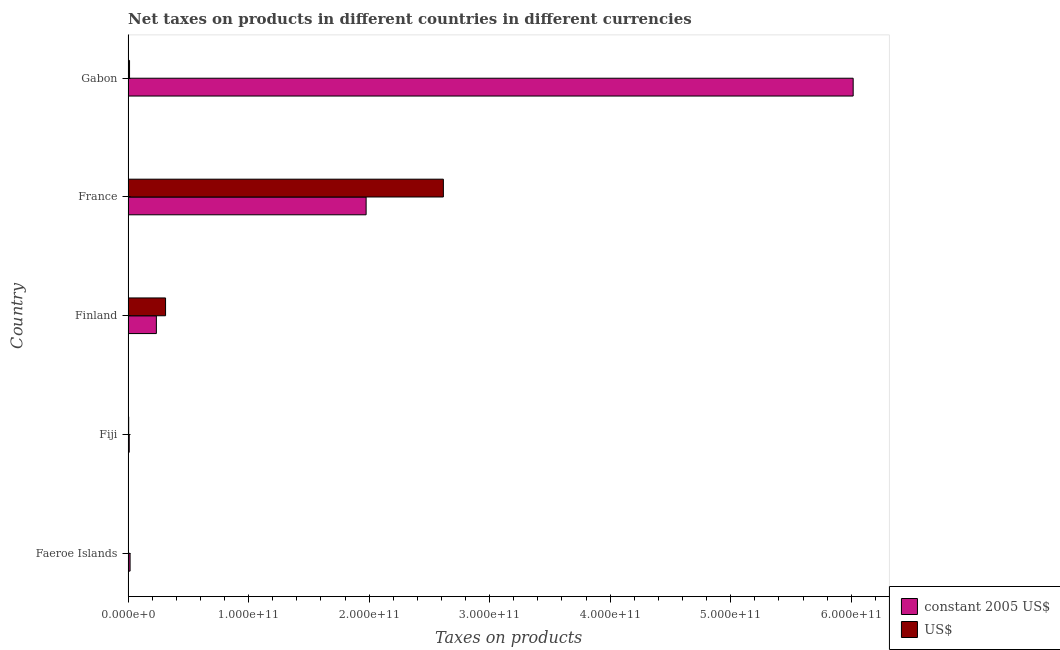How many groups of bars are there?
Offer a terse response. 5. How many bars are there on the 1st tick from the bottom?
Make the answer very short. 2. What is the label of the 4th group of bars from the top?
Provide a succinct answer. Fiji. In how many cases, is the number of bars for a given country not equal to the number of legend labels?
Your answer should be compact. 0. What is the net taxes in us$ in Fiji?
Offer a very short reply. 5.07e+08. Across all countries, what is the maximum net taxes in constant 2005 us$?
Offer a very short reply. 6.02e+11. Across all countries, what is the minimum net taxes in us$?
Your response must be concise. 2.96e+08. In which country was the net taxes in us$ maximum?
Provide a short and direct response. France. In which country was the net taxes in constant 2005 us$ minimum?
Your answer should be compact. Fiji. What is the total net taxes in us$ in the graph?
Offer a very short reply. 2.95e+11. What is the difference between the net taxes in us$ in Finland and that in Gabon?
Make the answer very short. 2.99e+1. What is the difference between the net taxes in us$ in Faeroe Islands and the net taxes in constant 2005 us$ in France?
Offer a terse response. -1.97e+11. What is the average net taxes in constant 2005 us$ per country?
Provide a succinct answer. 1.65e+11. What is the difference between the net taxes in constant 2005 us$ and net taxes in us$ in Finland?
Provide a short and direct response. -7.62e+09. What is the ratio of the net taxes in us$ in Faeroe Islands to that in Finland?
Provide a short and direct response. 0.01. Is the net taxes in us$ in Fiji less than that in Finland?
Give a very brief answer. Yes. Is the difference between the net taxes in us$ in Faeroe Islands and Finland greater than the difference between the net taxes in constant 2005 us$ in Faeroe Islands and Finland?
Offer a terse response. No. What is the difference between the highest and the second highest net taxes in constant 2005 us$?
Provide a succinct answer. 4.04e+11. What is the difference between the highest and the lowest net taxes in constant 2005 us$?
Make the answer very short. 6.01e+11. Is the sum of the net taxes in constant 2005 us$ in Faeroe Islands and France greater than the maximum net taxes in us$ across all countries?
Make the answer very short. No. What does the 2nd bar from the top in Finland represents?
Give a very brief answer. Constant 2005 us$. What does the 1st bar from the bottom in Finland represents?
Provide a succinct answer. Constant 2005 us$. How many bars are there?
Offer a terse response. 10. Are all the bars in the graph horizontal?
Ensure brevity in your answer.  Yes. How many countries are there in the graph?
Offer a terse response. 5. What is the difference between two consecutive major ticks on the X-axis?
Your answer should be very brief. 1.00e+11. Are the values on the major ticks of X-axis written in scientific E-notation?
Ensure brevity in your answer.  Yes. Does the graph contain any zero values?
Your answer should be very brief. No. How many legend labels are there?
Offer a terse response. 2. What is the title of the graph?
Your answer should be compact. Net taxes on products in different countries in different currencies. Does "Female population" appear as one of the legend labels in the graph?
Provide a succinct answer. No. What is the label or title of the X-axis?
Ensure brevity in your answer.  Taxes on products. What is the Taxes on products in constant 2005 US$ in Faeroe Islands?
Ensure brevity in your answer.  1.67e+09. What is the Taxes on products in US$ in Faeroe Islands?
Your answer should be very brief. 2.96e+08. What is the Taxes on products of constant 2005 US$ in Fiji?
Your answer should be compact. 9.73e+08. What is the Taxes on products in US$ in Fiji?
Provide a short and direct response. 5.07e+08. What is the Taxes on products of constant 2005 US$ in Finland?
Provide a short and direct response. 2.35e+1. What is the Taxes on products in US$ in Finland?
Offer a very short reply. 3.11e+1. What is the Taxes on products of constant 2005 US$ in France?
Ensure brevity in your answer.  1.97e+11. What is the Taxes on products in US$ in France?
Offer a very short reply. 2.62e+11. What is the Taxes on products in constant 2005 US$ in Gabon?
Your answer should be very brief. 6.02e+11. What is the Taxes on products of US$ in Gabon?
Offer a terse response. 1.21e+09. Across all countries, what is the maximum Taxes on products in constant 2005 US$?
Ensure brevity in your answer.  6.02e+11. Across all countries, what is the maximum Taxes on products of US$?
Your answer should be very brief. 2.62e+11. Across all countries, what is the minimum Taxes on products in constant 2005 US$?
Give a very brief answer. 9.73e+08. Across all countries, what is the minimum Taxes on products of US$?
Your response must be concise. 2.96e+08. What is the total Taxes on products of constant 2005 US$ in the graph?
Ensure brevity in your answer.  8.25e+11. What is the total Taxes on products of US$ in the graph?
Keep it short and to the point. 2.95e+11. What is the difference between the Taxes on products in constant 2005 US$ in Faeroe Islands and that in Fiji?
Ensure brevity in your answer.  6.93e+08. What is the difference between the Taxes on products in US$ in Faeroe Islands and that in Fiji?
Keep it short and to the point. -2.11e+08. What is the difference between the Taxes on products in constant 2005 US$ in Faeroe Islands and that in Finland?
Your response must be concise. -2.18e+1. What is the difference between the Taxes on products of US$ in Faeroe Islands and that in Finland?
Keep it short and to the point. -3.08e+1. What is the difference between the Taxes on products in constant 2005 US$ in Faeroe Islands and that in France?
Provide a succinct answer. -1.96e+11. What is the difference between the Taxes on products in US$ in Faeroe Islands and that in France?
Keep it short and to the point. -2.61e+11. What is the difference between the Taxes on products in constant 2005 US$ in Faeroe Islands and that in Gabon?
Provide a short and direct response. -6.00e+11. What is the difference between the Taxes on products in US$ in Faeroe Islands and that in Gabon?
Your response must be concise. -9.18e+08. What is the difference between the Taxes on products of constant 2005 US$ in Fiji and that in Finland?
Keep it short and to the point. -2.25e+1. What is the difference between the Taxes on products of US$ in Fiji and that in Finland?
Your answer should be very brief. -3.06e+1. What is the difference between the Taxes on products of constant 2005 US$ in Fiji and that in France?
Your answer should be very brief. -1.97e+11. What is the difference between the Taxes on products of US$ in Fiji and that in France?
Ensure brevity in your answer.  -2.61e+11. What is the difference between the Taxes on products in constant 2005 US$ in Fiji and that in Gabon?
Make the answer very short. -6.01e+11. What is the difference between the Taxes on products of US$ in Fiji and that in Gabon?
Provide a short and direct response. -7.07e+08. What is the difference between the Taxes on products in constant 2005 US$ in Finland and that in France?
Keep it short and to the point. -1.74e+11. What is the difference between the Taxes on products of US$ in Finland and that in France?
Make the answer very short. -2.30e+11. What is the difference between the Taxes on products in constant 2005 US$ in Finland and that in Gabon?
Offer a very short reply. -5.78e+11. What is the difference between the Taxes on products in US$ in Finland and that in Gabon?
Keep it short and to the point. 2.99e+1. What is the difference between the Taxes on products of constant 2005 US$ in France and that in Gabon?
Offer a very short reply. -4.04e+11. What is the difference between the Taxes on products of US$ in France and that in Gabon?
Provide a short and direct response. 2.60e+11. What is the difference between the Taxes on products in constant 2005 US$ in Faeroe Islands and the Taxes on products in US$ in Fiji?
Make the answer very short. 1.16e+09. What is the difference between the Taxes on products of constant 2005 US$ in Faeroe Islands and the Taxes on products of US$ in Finland?
Ensure brevity in your answer.  -2.94e+1. What is the difference between the Taxes on products in constant 2005 US$ in Faeroe Islands and the Taxes on products in US$ in France?
Your answer should be very brief. -2.60e+11. What is the difference between the Taxes on products of constant 2005 US$ in Faeroe Islands and the Taxes on products of US$ in Gabon?
Provide a short and direct response. 4.51e+08. What is the difference between the Taxes on products of constant 2005 US$ in Fiji and the Taxes on products of US$ in Finland?
Keep it short and to the point. -3.01e+1. What is the difference between the Taxes on products of constant 2005 US$ in Fiji and the Taxes on products of US$ in France?
Your answer should be very brief. -2.61e+11. What is the difference between the Taxes on products in constant 2005 US$ in Fiji and the Taxes on products in US$ in Gabon?
Make the answer very short. -2.41e+08. What is the difference between the Taxes on products in constant 2005 US$ in Finland and the Taxes on products in US$ in France?
Keep it short and to the point. -2.38e+11. What is the difference between the Taxes on products in constant 2005 US$ in Finland and the Taxes on products in US$ in Gabon?
Your answer should be very brief. 2.23e+1. What is the difference between the Taxes on products of constant 2005 US$ in France and the Taxes on products of US$ in Gabon?
Your answer should be very brief. 1.96e+11. What is the average Taxes on products of constant 2005 US$ per country?
Your answer should be compact. 1.65e+11. What is the average Taxes on products in US$ per country?
Ensure brevity in your answer.  5.89e+1. What is the difference between the Taxes on products of constant 2005 US$ and Taxes on products of US$ in Faeroe Islands?
Provide a succinct answer. 1.37e+09. What is the difference between the Taxes on products in constant 2005 US$ and Taxes on products in US$ in Fiji?
Offer a terse response. 4.66e+08. What is the difference between the Taxes on products of constant 2005 US$ and Taxes on products of US$ in Finland?
Provide a succinct answer. -7.62e+09. What is the difference between the Taxes on products of constant 2005 US$ and Taxes on products of US$ in France?
Offer a very short reply. -6.41e+1. What is the difference between the Taxes on products in constant 2005 US$ and Taxes on products in US$ in Gabon?
Offer a terse response. 6.00e+11. What is the ratio of the Taxes on products of constant 2005 US$ in Faeroe Islands to that in Fiji?
Provide a short and direct response. 1.71. What is the ratio of the Taxes on products in US$ in Faeroe Islands to that in Fiji?
Your response must be concise. 0.58. What is the ratio of the Taxes on products of constant 2005 US$ in Faeroe Islands to that in Finland?
Give a very brief answer. 0.07. What is the ratio of the Taxes on products in US$ in Faeroe Islands to that in Finland?
Your answer should be very brief. 0.01. What is the ratio of the Taxes on products in constant 2005 US$ in Faeroe Islands to that in France?
Give a very brief answer. 0.01. What is the ratio of the Taxes on products of US$ in Faeroe Islands to that in France?
Provide a short and direct response. 0. What is the ratio of the Taxes on products of constant 2005 US$ in Faeroe Islands to that in Gabon?
Make the answer very short. 0. What is the ratio of the Taxes on products in US$ in Faeroe Islands to that in Gabon?
Make the answer very short. 0.24. What is the ratio of the Taxes on products in constant 2005 US$ in Fiji to that in Finland?
Keep it short and to the point. 0.04. What is the ratio of the Taxes on products in US$ in Fiji to that in Finland?
Offer a very short reply. 0.02. What is the ratio of the Taxes on products of constant 2005 US$ in Fiji to that in France?
Your answer should be very brief. 0. What is the ratio of the Taxes on products of US$ in Fiji to that in France?
Give a very brief answer. 0. What is the ratio of the Taxes on products of constant 2005 US$ in Fiji to that in Gabon?
Your answer should be compact. 0. What is the ratio of the Taxes on products in US$ in Fiji to that in Gabon?
Keep it short and to the point. 0.42. What is the ratio of the Taxes on products in constant 2005 US$ in Finland to that in France?
Keep it short and to the point. 0.12. What is the ratio of the Taxes on products of US$ in Finland to that in France?
Make the answer very short. 0.12. What is the ratio of the Taxes on products in constant 2005 US$ in Finland to that in Gabon?
Your answer should be very brief. 0.04. What is the ratio of the Taxes on products of US$ in Finland to that in Gabon?
Offer a very short reply. 25.6. What is the ratio of the Taxes on products of constant 2005 US$ in France to that in Gabon?
Offer a very short reply. 0.33. What is the ratio of the Taxes on products of US$ in France to that in Gabon?
Your response must be concise. 215.36. What is the difference between the highest and the second highest Taxes on products of constant 2005 US$?
Your response must be concise. 4.04e+11. What is the difference between the highest and the second highest Taxes on products in US$?
Give a very brief answer. 2.30e+11. What is the difference between the highest and the lowest Taxes on products of constant 2005 US$?
Your answer should be very brief. 6.01e+11. What is the difference between the highest and the lowest Taxes on products in US$?
Your answer should be compact. 2.61e+11. 